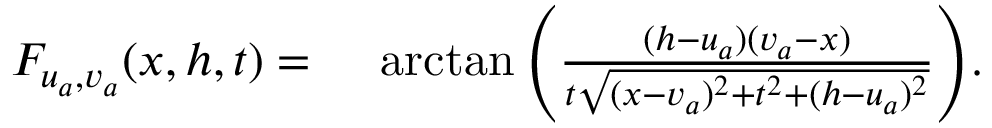<formula> <loc_0><loc_0><loc_500><loc_500>\begin{array} { r l } { F _ { u _ { a } , v _ { a } } ( x , h , t ) } & \arctan { \left ( \frac { ( h - u _ { a } ) ( v _ { a } - x ) } { t \sqrt { ( x - v _ { a } ) ^ { 2 } + t ^ { 2 } + ( h - u _ { a } ) ^ { 2 } } } \right ) } . } \end{array}</formula> 